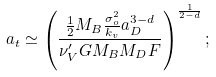Convert formula to latex. <formula><loc_0><loc_0><loc_500><loc_500>a _ { t } \simeq \left ( \frac { \frac { 1 } { 2 } M _ { B } \frac { \sigma _ { o } ^ { 2 } } { k _ { v } } a _ { D } ^ { 3 - d } } { \nu ^ { \prime } _ { V } G M _ { B } M _ { D } F } \right ) ^ { \frac { 1 } { 2 - d } } ;</formula> 